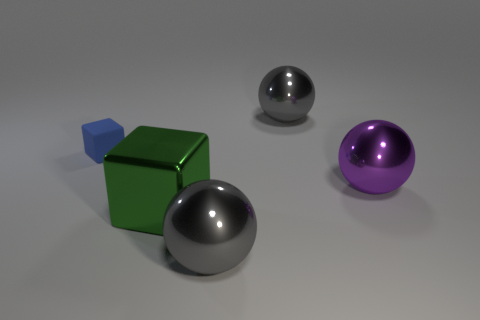Subtract all big gray metallic spheres. How many spheres are left? 1 Add 2 large rubber cylinders. How many objects exist? 7 Subtract 1 spheres. How many spheres are left? 2 Subtract all purple balls. How many balls are left? 2 Subtract all red spheres. How many blue cubes are left? 1 Subtract all tiny blue matte cubes. Subtract all big purple shiny balls. How many objects are left? 3 Add 1 large spheres. How many large spheres are left? 4 Add 3 large gray balls. How many large gray balls exist? 5 Subtract 0 brown cylinders. How many objects are left? 5 Subtract all blocks. How many objects are left? 3 